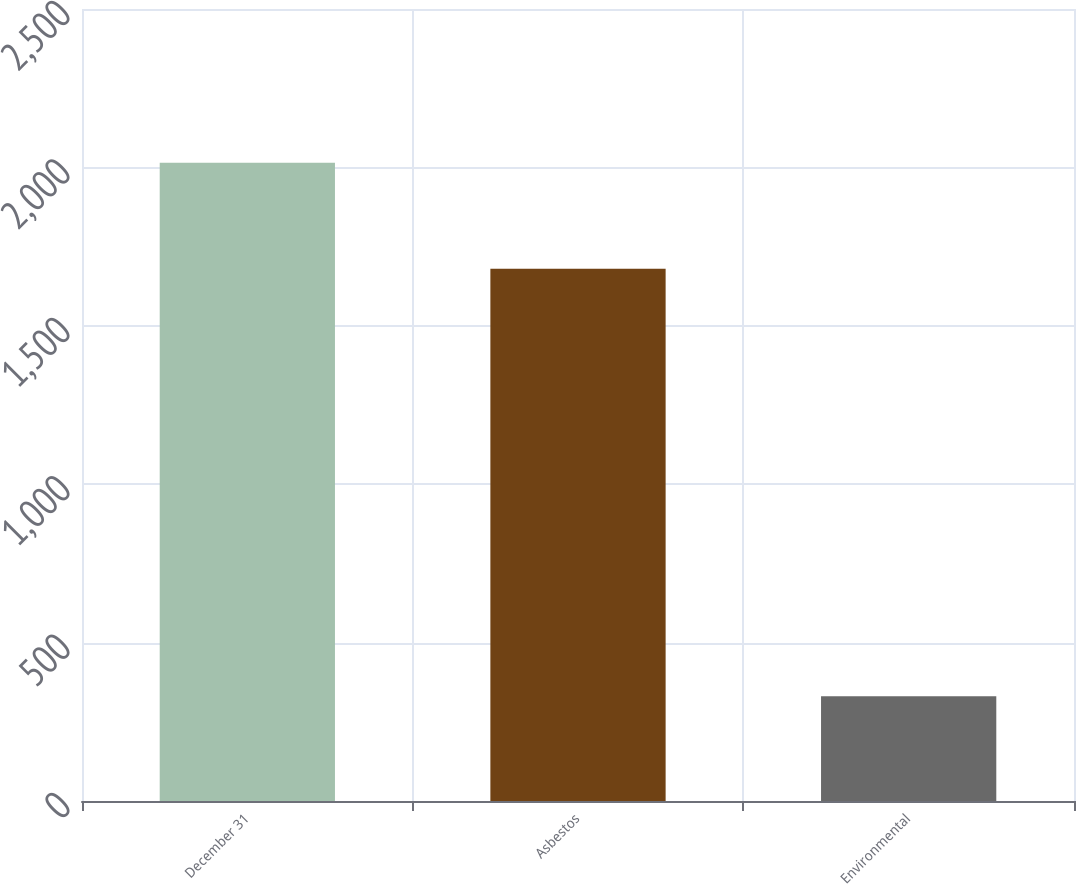Convert chart to OTSL. <chart><loc_0><loc_0><loc_500><loc_500><bar_chart><fcel>December 31<fcel>Asbestos<fcel>Environmental<nl><fcel>2015<fcel>1680<fcel>331<nl></chart> 